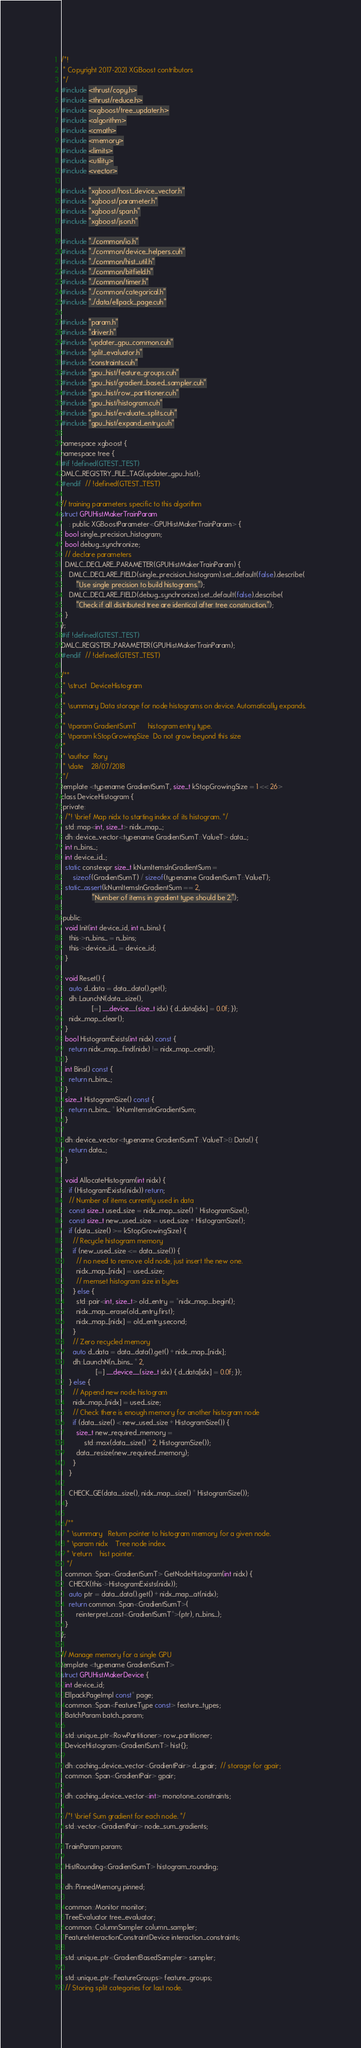Convert code to text. <code><loc_0><loc_0><loc_500><loc_500><_Cuda_>/*!
 * Copyright 2017-2021 XGBoost contributors
 */
#include <thrust/copy.h>
#include <thrust/reduce.h>
#include <xgboost/tree_updater.h>
#include <algorithm>
#include <cmath>
#include <memory>
#include <limits>
#include <utility>
#include <vector>

#include "xgboost/host_device_vector.h"
#include "xgboost/parameter.h"
#include "xgboost/span.h"
#include "xgboost/json.h"

#include "../common/io.h"
#include "../common/device_helpers.cuh"
#include "../common/hist_util.h"
#include "../common/bitfield.h"
#include "../common/timer.h"
#include "../common/categorical.h"
#include "../data/ellpack_page.cuh"

#include "param.h"
#include "driver.h"
#include "updater_gpu_common.cuh"
#include "split_evaluator.h"
#include "constraints.cuh"
#include "gpu_hist/feature_groups.cuh"
#include "gpu_hist/gradient_based_sampler.cuh"
#include "gpu_hist/row_partitioner.cuh"
#include "gpu_hist/histogram.cuh"
#include "gpu_hist/evaluate_splits.cuh"
#include "gpu_hist/expand_entry.cuh"

namespace xgboost {
namespace tree {
#if !defined(GTEST_TEST)
DMLC_REGISTRY_FILE_TAG(updater_gpu_hist);
#endif  // !defined(GTEST_TEST)

// training parameters specific to this algorithm
struct GPUHistMakerTrainParam
    : public XGBoostParameter<GPUHistMakerTrainParam> {
  bool single_precision_histogram;
  bool debug_synchronize;
  // declare parameters
  DMLC_DECLARE_PARAMETER(GPUHistMakerTrainParam) {
    DMLC_DECLARE_FIELD(single_precision_histogram).set_default(false).describe(
        "Use single precision to build histograms.");
    DMLC_DECLARE_FIELD(debug_synchronize).set_default(false).describe(
        "Check if all distributed tree are identical after tree construction.");
  }
};
#if !defined(GTEST_TEST)
DMLC_REGISTER_PARAMETER(GPUHistMakerTrainParam);
#endif  // !defined(GTEST_TEST)

/**
 * \struct  DeviceHistogram
 *
 * \summary Data storage for node histograms on device. Automatically expands.
 *
 * \tparam GradientSumT      histogram entry type.
 * \tparam kStopGrowingSize  Do not grow beyond this size
 *
 * \author  Rory
 * \date    28/07/2018
 */
template <typename GradientSumT, size_t kStopGrowingSize = 1 << 26>
class DeviceHistogram {
 private:
  /*! \brief Map nidx to starting index of its histogram. */
  std::map<int, size_t> nidx_map_;
  dh::device_vector<typename GradientSumT::ValueT> data_;
  int n_bins_;
  int device_id_;
  static constexpr size_t kNumItemsInGradientSum =
      sizeof(GradientSumT) / sizeof(typename GradientSumT::ValueT);
  static_assert(kNumItemsInGradientSum == 2,
                "Number of items in gradient type should be 2.");

 public:
  void Init(int device_id, int n_bins) {
    this->n_bins_ = n_bins;
    this->device_id_ = device_id;
  }

  void Reset() {
    auto d_data = data_.data().get();
    dh::LaunchN(data_.size(),
                [=] __device__(size_t idx) { d_data[idx] = 0.0f; });
    nidx_map_.clear();
  }
  bool HistogramExists(int nidx) const {
    return nidx_map_.find(nidx) != nidx_map_.cend();
  }
  int Bins() const {
    return n_bins_;
  }
  size_t HistogramSize() const {
    return n_bins_ * kNumItemsInGradientSum;
  }

  dh::device_vector<typename GradientSumT::ValueT>& Data() {
    return data_;
  }

  void AllocateHistogram(int nidx) {
    if (HistogramExists(nidx)) return;
    // Number of items currently used in data
    const size_t used_size = nidx_map_.size() * HistogramSize();
    const size_t new_used_size = used_size + HistogramSize();
    if (data_.size() >= kStopGrowingSize) {
      // Recycle histogram memory
      if (new_used_size <= data_.size()) {
        // no need to remove old node, just insert the new one.
        nidx_map_[nidx] = used_size;
        // memset histogram size in bytes
      } else {
        std::pair<int, size_t> old_entry = *nidx_map_.begin();
        nidx_map_.erase(old_entry.first);
        nidx_map_[nidx] = old_entry.second;
      }
      // Zero recycled memory
      auto d_data = data_.data().get() + nidx_map_[nidx];
      dh::LaunchN(n_bins_ * 2,
                  [=] __device__(size_t idx) { d_data[idx] = 0.0f; });
    } else {
      // Append new node histogram
      nidx_map_[nidx] = used_size;
      // Check there is enough memory for another histogram node
      if (data_.size() < new_used_size + HistogramSize()) {
        size_t new_required_memory =
            std::max(data_.size() * 2, HistogramSize());
        data_.resize(new_required_memory);
      }
    }

    CHECK_GE(data_.size(), nidx_map_.size() * HistogramSize());
  }

  /**
   * \summary   Return pointer to histogram memory for a given node.
   * \param nidx    Tree node index.
   * \return    hist pointer.
   */
  common::Span<GradientSumT> GetNodeHistogram(int nidx) {
    CHECK(this->HistogramExists(nidx));
    auto ptr = data_.data().get() + nidx_map_.at(nidx);
    return common::Span<GradientSumT>(
        reinterpret_cast<GradientSumT*>(ptr), n_bins_);
  }
};

// Manage memory for a single GPU
template <typename GradientSumT>
struct GPUHistMakerDevice {
  int device_id;
  EllpackPageImpl const* page;
  common::Span<FeatureType const> feature_types;
  BatchParam batch_param;

  std::unique_ptr<RowPartitioner> row_partitioner;
  DeviceHistogram<GradientSumT> hist{};

  dh::caching_device_vector<GradientPair> d_gpair;  // storage for gpair;
  common::Span<GradientPair> gpair;

  dh::caching_device_vector<int> monotone_constraints;

  /*! \brief Sum gradient for each node. */
  std::vector<GradientPair> node_sum_gradients;

  TrainParam param;

  HistRounding<GradientSumT> histogram_rounding;

  dh::PinnedMemory pinned;

  common::Monitor monitor;
  TreeEvaluator tree_evaluator;
  common::ColumnSampler column_sampler;
  FeatureInteractionConstraintDevice interaction_constraints;

  std::unique_ptr<GradientBasedSampler> sampler;

  std::unique_ptr<FeatureGroups> feature_groups;
  // Storing split categories for last node.</code> 